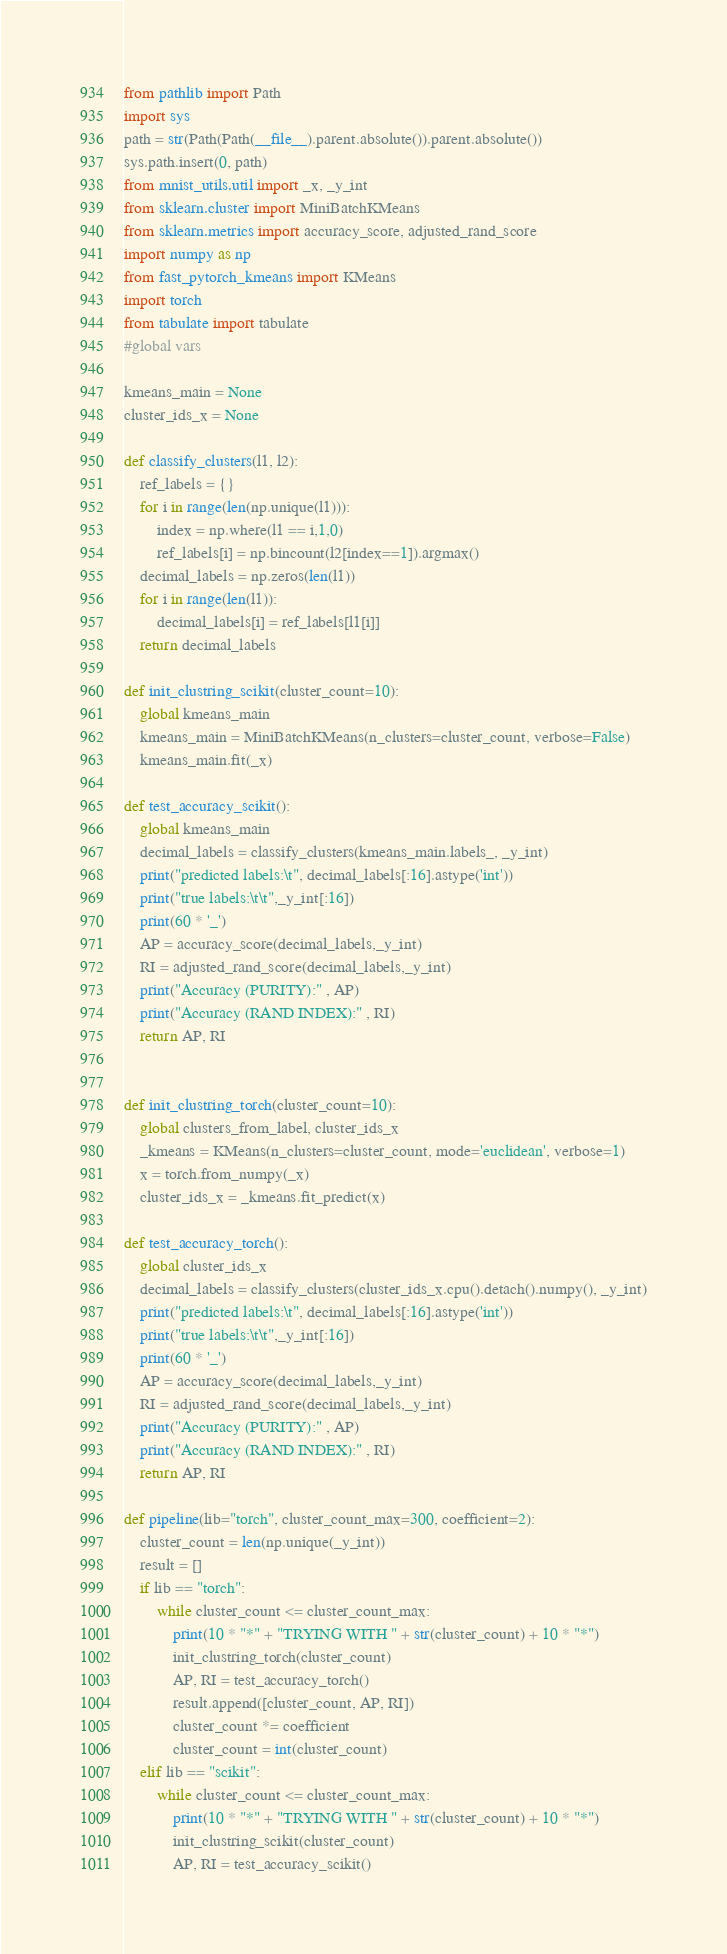<code> <loc_0><loc_0><loc_500><loc_500><_Python_>from pathlib import Path
import sys
path = str(Path(Path(__file__).parent.absolute()).parent.absolute())
sys.path.insert(0, path)
from mnist_utils.util import _x, _y_int
from sklearn.cluster import MiniBatchKMeans
from sklearn.metrics import accuracy_score, adjusted_rand_score
import numpy as np
from fast_pytorch_kmeans import KMeans
import torch
from tabulate import tabulate
#global vars

kmeans_main = None
cluster_ids_x = None

def classify_clusters(l1, l2):
    ref_labels = {}
    for i in range(len(np.unique(l1))):
        index = np.where(l1 == i,1,0)
        ref_labels[i] = np.bincount(l2[index==1]).argmax()
    decimal_labels = np.zeros(len(l1))
    for i in range(len(l1)):
        decimal_labels[i] = ref_labels[l1[i]]
    return decimal_labels

def init_clustring_scikit(cluster_count=10):
    global kmeans_main
    kmeans_main = MiniBatchKMeans(n_clusters=cluster_count, verbose=False)
    kmeans_main.fit(_x)

def test_accuracy_scikit():
    global kmeans_main
    decimal_labels = classify_clusters(kmeans_main.labels_, _y_int)
    print("predicted labels:\t", decimal_labels[:16].astype('int'))
    print("true labels:\t\t",_y_int[:16])
    print(60 * '_')
    AP = accuracy_score(decimal_labels,_y_int)
    RI = adjusted_rand_score(decimal_labels,_y_int)
    print("Accuracy (PURITY):" , AP)
    print("Accuracy (RAND INDEX):" , RI)
    return AP, RI


def init_clustring_torch(cluster_count=10):
    global clusters_from_label, cluster_ids_x
    _kmeans = KMeans(n_clusters=cluster_count, mode='euclidean', verbose=1)
    x = torch.from_numpy(_x)
    cluster_ids_x = _kmeans.fit_predict(x)

def test_accuracy_torch():
    global cluster_ids_x 
    decimal_labels = classify_clusters(cluster_ids_x.cpu().detach().numpy(), _y_int)
    print("predicted labels:\t", decimal_labels[:16].astype('int'))
    print("true labels:\t\t",_y_int[:16])
    print(60 * '_')
    AP = accuracy_score(decimal_labels,_y_int)
    RI = adjusted_rand_score(decimal_labels,_y_int)
    print("Accuracy (PURITY):" , AP)
    print("Accuracy (RAND INDEX):" , RI)
    return AP, RI

def pipeline(lib="torch", cluster_count_max=300, coefficient=2):
    cluster_count = len(np.unique(_y_int))
    result = []
    if lib == "torch":
        while cluster_count <= cluster_count_max:
            print(10 * "*" + "TRYING WITH " + str(cluster_count) + 10 * "*")
            init_clustring_torch(cluster_count)
            AP, RI = test_accuracy_torch() 
            result.append([cluster_count, AP, RI])
            cluster_count *= coefficient
            cluster_count = int(cluster_count)
    elif lib == "scikit":
        while cluster_count <= cluster_count_max:
            print(10 * "*" + "TRYING WITH " + str(cluster_count) + 10 * "*")
            init_clustring_scikit(cluster_count)
            AP, RI = test_accuracy_scikit() </code> 